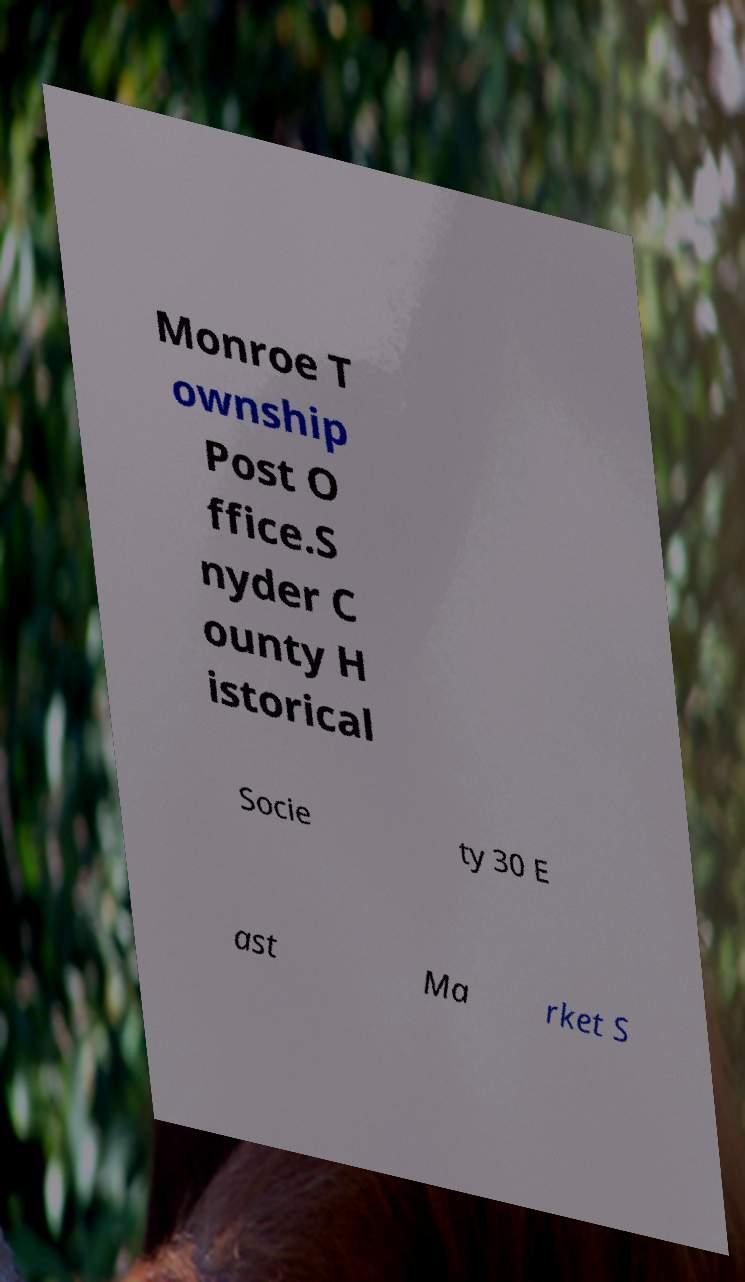Could you assist in decoding the text presented in this image and type it out clearly? Monroe T ownship Post O ffice.S nyder C ounty H istorical Socie ty 30 E ast Ma rket S 